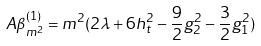Convert formula to latex. <formula><loc_0><loc_0><loc_500><loc_500>A \beta _ { m ^ { 2 } } ^ { ( 1 ) } = m ^ { 2 } ( 2 \lambda + 6 h _ { t } ^ { 2 } - \frac { 9 } { 2 } g _ { 2 } ^ { 2 } - \frac { 3 } { 2 } g _ { 1 } ^ { 2 } )</formula> 